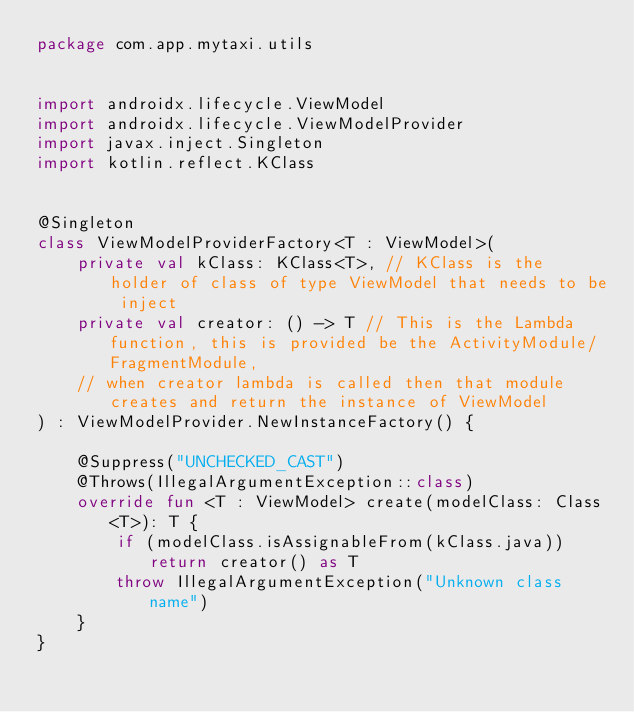<code> <loc_0><loc_0><loc_500><loc_500><_Kotlin_>package com.app.mytaxi.utils


import androidx.lifecycle.ViewModel
import androidx.lifecycle.ViewModelProvider
import javax.inject.Singleton
import kotlin.reflect.KClass


@Singleton
class ViewModelProviderFactory<T : ViewModel>(
    private val kClass: KClass<T>, // KClass is the holder of class of type ViewModel that needs to be inject
    private val creator: () -> T // This is the Lambda function, this is provided be the ActivityModule/FragmentModule,
    // when creator lambda is called then that module creates and return the instance of ViewModel
) : ViewModelProvider.NewInstanceFactory() {

    @Suppress("UNCHECKED_CAST")
    @Throws(IllegalArgumentException::class)
    override fun <T : ViewModel> create(modelClass: Class<T>): T {
        if (modelClass.isAssignableFrom(kClass.java)) return creator() as T
        throw IllegalArgumentException("Unknown class name")
    }
}
</code> 